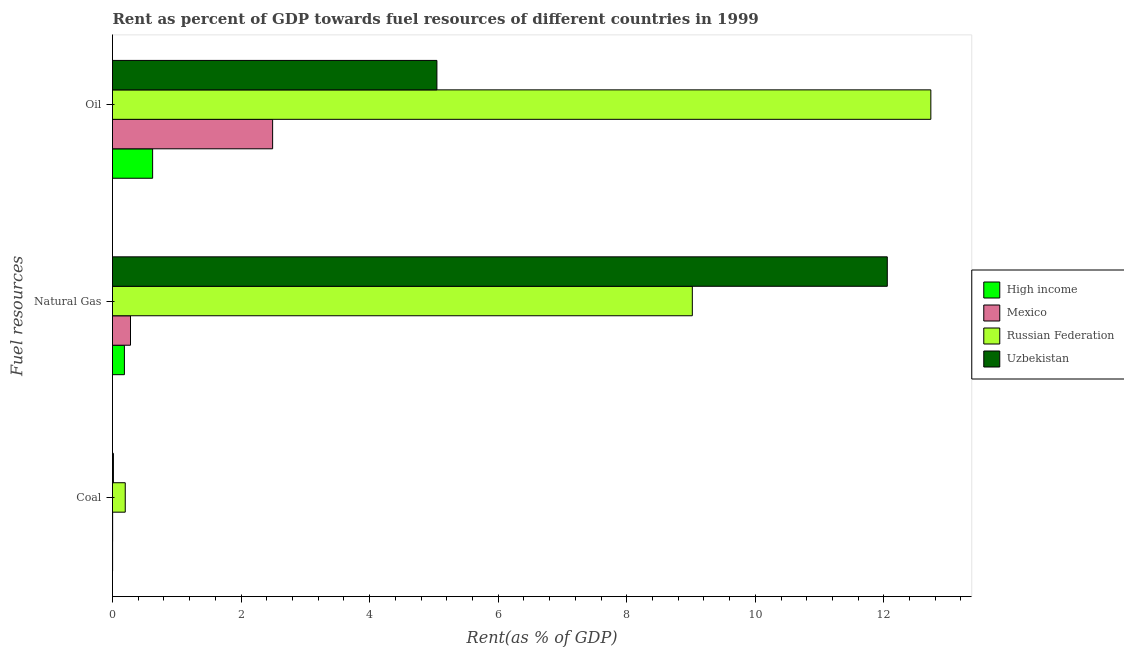How many different coloured bars are there?
Offer a terse response. 4. How many groups of bars are there?
Provide a short and direct response. 3. How many bars are there on the 2nd tick from the top?
Offer a terse response. 4. What is the label of the 1st group of bars from the top?
Ensure brevity in your answer.  Oil. What is the rent towards oil in Mexico?
Give a very brief answer. 2.49. Across all countries, what is the maximum rent towards coal?
Your response must be concise. 0.2. Across all countries, what is the minimum rent towards natural gas?
Give a very brief answer. 0.19. In which country was the rent towards coal maximum?
Provide a succinct answer. Russian Federation. In which country was the rent towards natural gas minimum?
Your answer should be very brief. High income. What is the total rent towards oil in the graph?
Your response must be concise. 20.89. What is the difference between the rent towards natural gas in Russian Federation and that in Uzbekistan?
Ensure brevity in your answer.  -3.03. What is the difference between the rent towards coal in High income and the rent towards natural gas in Russian Federation?
Your response must be concise. -9.02. What is the average rent towards coal per country?
Keep it short and to the point. 0.05. What is the difference between the rent towards natural gas and rent towards oil in Mexico?
Provide a succinct answer. -2.21. What is the ratio of the rent towards oil in High income to that in Uzbekistan?
Ensure brevity in your answer.  0.12. Is the rent towards natural gas in Russian Federation less than that in Uzbekistan?
Your response must be concise. Yes. What is the difference between the highest and the second highest rent towards natural gas?
Offer a very short reply. 3.03. What is the difference between the highest and the lowest rent towards natural gas?
Your answer should be compact. 11.87. In how many countries, is the rent towards oil greater than the average rent towards oil taken over all countries?
Your answer should be compact. 1. Is the sum of the rent towards natural gas in High income and Mexico greater than the maximum rent towards oil across all countries?
Make the answer very short. No. What does the 1st bar from the top in Oil represents?
Give a very brief answer. Uzbekistan. What does the 3rd bar from the bottom in Coal represents?
Provide a succinct answer. Russian Federation. Is it the case that in every country, the sum of the rent towards coal and rent towards natural gas is greater than the rent towards oil?
Provide a succinct answer. No. How many bars are there?
Provide a succinct answer. 12. What is the difference between two consecutive major ticks on the X-axis?
Provide a short and direct response. 2. Does the graph contain any zero values?
Ensure brevity in your answer.  No. Where does the legend appear in the graph?
Offer a terse response. Center right. How many legend labels are there?
Your answer should be compact. 4. What is the title of the graph?
Your answer should be very brief. Rent as percent of GDP towards fuel resources of different countries in 1999. What is the label or title of the X-axis?
Your response must be concise. Rent(as % of GDP). What is the label or title of the Y-axis?
Give a very brief answer. Fuel resources. What is the Rent(as % of GDP) of High income in Coal?
Your response must be concise. 0. What is the Rent(as % of GDP) in Mexico in Coal?
Ensure brevity in your answer.  0. What is the Rent(as % of GDP) in Russian Federation in Coal?
Your answer should be compact. 0.2. What is the Rent(as % of GDP) in Uzbekistan in Coal?
Make the answer very short. 0.01. What is the Rent(as % of GDP) of High income in Natural Gas?
Your answer should be compact. 0.19. What is the Rent(as % of GDP) in Mexico in Natural Gas?
Ensure brevity in your answer.  0.28. What is the Rent(as % of GDP) in Russian Federation in Natural Gas?
Keep it short and to the point. 9.02. What is the Rent(as % of GDP) of Uzbekistan in Natural Gas?
Provide a short and direct response. 12.05. What is the Rent(as % of GDP) of High income in Oil?
Ensure brevity in your answer.  0.62. What is the Rent(as % of GDP) of Mexico in Oil?
Your answer should be compact. 2.49. What is the Rent(as % of GDP) in Russian Federation in Oil?
Ensure brevity in your answer.  12.73. What is the Rent(as % of GDP) of Uzbekistan in Oil?
Offer a terse response. 5.05. Across all Fuel resources, what is the maximum Rent(as % of GDP) of High income?
Your response must be concise. 0.62. Across all Fuel resources, what is the maximum Rent(as % of GDP) in Mexico?
Provide a succinct answer. 2.49. Across all Fuel resources, what is the maximum Rent(as % of GDP) of Russian Federation?
Your response must be concise. 12.73. Across all Fuel resources, what is the maximum Rent(as % of GDP) of Uzbekistan?
Your answer should be compact. 12.05. Across all Fuel resources, what is the minimum Rent(as % of GDP) in High income?
Keep it short and to the point. 0. Across all Fuel resources, what is the minimum Rent(as % of GDP) of Mexico?
Offer a terse response. 0. Across all Fuel resources, what is the minimum Rent(as % of GDP) of Russian Federation?
Your answer should be compact. 0.2. Across all Fuel resources, what is the minimum Rent(as % of GDP) in Uzbekistan?
Your answer should be very brief. 0.01. What is the total Rent(as % of GDP) in High income in the graph?
Give a very brief answer. 0.81. What is the total Rent(as % of GDP) of Mexico in the graph?
Your answer should be compact. 2.77. What is the total Rent(as % of GDP) of Russian Federation in the graph?
Provide a succinct answer. 21.95. What is the total Rent(as % of GDP) in Uzbekistan in the graph?
Offer a very short reply. 17.11. What is the difference between the Rent(as % of GDP) in High income in Coal and that in Natural Gas?
Offer a very short reply. -0.18. What is the difference between the Rent(as % of GDP) of Mexico in Coal and that in Natural Gas?
Your answer should be compact. -0.28. What is the difference between the Rent(as % of GDP) in Russian Federation in Coal and that in Natural Gas?
Provide a short and direct response. -8.82. What is the difference between the Rent(as % of GDP) in Uzbekistan in Coal and that in Natural Gas?
Offer a terse response. -12.04. What is the difference between the Rent(as % of GDP) of High income in Coal and that in Oil?
Your response must be concise. -0.62. What is the difference between the Rent(as % of GDP) in Mexico in Coal and that in Oil?
Keep it short and to the point. -2.49. What is the difference between the Rent(as % of GDP) of Russian Federation in Coal and that in Oil?
Offer a terse response. -12.53. What is the difference between the Rent(as % of GDP) of Uzbekistan in Coal and that in Oil?
Give a very brief answer. -5.03. What is the difference between the Rent(as % of GDP) in High income in Natural Gas and that in Oil?
Give a very brief answer. -0.44. What is the difference between the Rent(as % of GDP) of Mexico in Natural Gas and that in Oil?
Your answer should be compact. -2.21. What is the difference between the Rent(as % of GDP) of Russian Federation in Natural Gas and that in Oil?
Make the answer very short. -3.71. What is the difference between the Rent(as % of GDP) in Uzbekistan in Natural Gas and that in Oil?
Ensure brevity in your answer.  7.01. What is the difference between the Rent(as % of GDP) of High income in Coal and the Rent(as % of GDP) of Mexico in Natural Gas?
Ensure brevity in your answer.  -0.28. What is the difference between the Rent(as % of GDP) of High income in Coal and the Rent(as % of GDP) of Russian Federation in Natural Gas?
Ensure brevity in your answer.  -9.02. What is the difference between the Rent(as % of GDP) of High income in Coal and the Rent(as % of GDP) of Uzbekistan in Natural Gas?
Your response must be concise. -12.05. What is the difference between the Rent(as % of GDP) of Mexico in Coal and the Rent(as % of GDP) of Russian Federation in Natural Gas?
Your answer should be compact. -9.02. What is the difference between the Rent(as % of GDP) in Mexico in Coal and the Rent(as % of GDP) in Uzbekistan in Natural Gas?
Provide a short and direct response. -12.05. What is the difference between the Rent(as % of GDP) in Russian Federation in Coal and the Rent(as % of GDP) in Uzbekistan in Natural Gas?
Ensure brevity in your answer.  -11.86. What is the difference between the Rent(as % of GDP) of High income in Coal and the Rent(as % of GDP) of Mexico in Oil?
Provide a short and direct response. -2.49. What is the difference between the Rent(as % of GDP) in High income in Coal and the Rent(as % of GDP) in Russian Federation in Oil?
Ensure brevity in your answer.  -12.73. What is the difference between the Rent(as % of GDP) of High income in Coal and the Rent(as % of GDP) of Uzbekistan in Oil?
Make the answer very short. -5.05. What is the difference between the Rent(as % of GDP) in Mexico in Coal and the Rent(as % of GDP) in Russian Federation in Oil?
Your response must be concise. -12.73. What is the difference between the Rent(as % of GDP) of Mexico in Coal and the Rent(as % of GDP) of Uzbekistan in Oil?
Your response must be concise. -5.04. What is the difference between the Rent(as % of GDP) in Russian Federation in Coal and the Rent(as % of GDP) in Uzbekistan in Oil?
Offer a terse response. -4.85. What is the difference between the Rent(as % of GDP) of High income in Natural Gas and the Rent(as % of GDP) of Mexico in Oil?
Offer a very short reply. -2.31. What is the difference between the Rent(as % of GDP) of High income in Natural Gas and the Rent(as % of GDP) of Russian Federation in Oil?
Your answer should be compact. -12.55. What is the difference between the Rent(as % of GDP) in High income in Natural Gas and the Rent(as % of GDP) in Uzbekistan in Oil?
Provide a succinct answer. -4.86. What is the difference between the Rent(as % of GDP) in Mexico in Natural Gas and the Rent(as % of GDP) in Russian Federation in Oil?
Give a very brief answer. -12.45. What is the difference between the Rent(as % of GDP) in Mexico in Natural Gas and the Rent(as % of GDP) in Uzbekistan in Oil?
Offer a very short reply. -4.77. What is the difference between the Rent(as % of GDP) in Russian Federation in Natural Gas and the Rent(as % of GDP) in Uzbekistan in Oil?
Ensure brevity in your answer.  3.97. What is the average Rent(as % of GDP) in High income per Fuel resources?
Your answer should be very brief. 0.27. What is the average Rent(as % of GDP) of Mexico per Fuel resources?
Offer a very short reply. 0.92. What is the average Rent(as % of GDP) in Russian Federation per Fuel resources?
Offer a terse response. 7.32. What is the average Rent(as % of GDP) in Uzbekistan per Fuel resources?
Your answer should be compact. 5.7. What is the difference between the Rent(as % of GDP) of High income and Rent(as % of GDP) of Mexico in Coal?
Provide a succinct answer. -0. What is the difference between the Rent(as % of GDP) in High income and Rent(as % of GDP) in Russian Federation in Coal?
Provide a short and direct response. -0.2. What is the difference between the Rent(as % of GDP) of High income and Rent(as % of GDP) of Uzbekistan in Coal?
Your answer should be very brief. -0.01. What is the difference between the Rent(as % of GDP) in Mexico and Rent(as % of GDP) in Russian Federation in Coal?
Your answer should be very brief. -0.2. What is the difference between the Rent(as % of GDP) of Mexico and Rent(as % of GDP) of Uzbekistan in Coal?
Your response must be concise. -0.01. What is the difference between the Rent(as % of GDP) of Russian Federation and Rent(as % of GDP) of Uzbekistan in Coal?
Your answer should be very brief. 0.18. What is the difference between the Rent(as % of GDP) in High income and Rent(as % of GDP) in Mexico in Natural Gas?
Your answer should be compact. -0.09. What is the difference between the Rent(as % of GDP) of High income and Rent(as % of GDP) of Russian Federation in Natural Gas?
Offer a very short reply. -8.84. What is the difference between the Rent(as % of GDP) in High income and Rent(as % of GDP) in Uzbekistan in Natural Gas?
Ensure brevity in your answer.  -11.87. What is the difference between the Rent(as % of GDP) in Mexico and Rent(as % of GDP) in Russian Federation in Natural Gas?
Your answer should be compact. -8.74. What is the difference between the Rent(as % of GDP) of Mexico and Rent(as % of GDP) of Uzbekistan in Natural Gas?
Provide a short and direct response. -11.77. What is the difference between the Rent(as % of GDP) in Russian Federation and Rent(as % of GDP) in Uzbekistan in Natural Gas?
Ensure brevity in your answer.  -3.03. What is the difference between the Rent(as % of GDP) in High income and Rent(as % of GDP) in Mexico in Oil?
Offer a terse response. -1.87. What is the difference between the Rent(as % of GDP) of High income and Rent(as % of GDP) of Russian Federation in Oil?
Ensure brevity in your answer.  -12.11. What is the difference between the Rent(as % of GDP) of High income and Rent(as % of GDP) of Uzbekistan in Oil?
Provide a succinct answer. -4.42. What is the difference between the Rent(as % of GDP) of Mexico and Rent(as % of GDP) of Russian Federation in Oil?
Offer a terse response. -10.24. What is the difference between the Rent(as % of GDP) in Mexico and Rent(as % of GDP) in Uzbekistan in Oil?
Offer a very short reply. -2.56. What is the difference between the Rent(as % of GDP) in Russian Federation and Rent(as % of GDP) in Uzbekistan in Oil?
Your answer should be very brief. 7.68. What is the ratio of the Rent(as % of GDP) in High income in Coal to that in Natural Gas?
Your answer should be compact. 0.01. What is the ratio of the Rent(as % of GDP) in Mexico in Coal to that in Natural Gas?
Provide a succinct answer. 0.01. What is the ratio of the Rent(as % of GDP) of Russian Federation in Coal to that in Natural Gas?
Offer a terse response. 0.02. What is the ratio of the Rent(as % of GDP) of Uzbekistan in Coal to that in Natural Gas?
Provide a succinct answer. 0. What is the ratio of the Rent(as % of GDP) of High income in Coal to that in Oil?
Ensure brevity in your answer.  0. What is the ratio of the Rent(as % of GDP) in Mexico in Coal to that in Oil?
Your answer should be compact. 0. What is the ratio of the Rent(as % of GDP) of Russian Federation in Coal to that in Oil?
Offer a very short reply. 0.02. What is the ratio of the Rent(as % of GDP) in Uzbekistan in Coal to that in Oil?
Your answer should be very brief. 0. What is the ratio of the Rent(as % of GDP) in High income in Natural Gas to that in Oil?
Your response must be concise. 0.3. What is the ratio of the Rent(as % of GDP) in Mexico in Natural Gas to that in Oil?
Your response must be concise. 0.11. What is the ratio of the Rent(as % of GDP) in Russian Federation in Natural Gas to that in Oil?
Keep it short and to the point. 0.71. What is the ratio of the Rent(as % of GDP) in Uzbekistan in Natural Gas to that in Oil?
Make the answer very short. 2.39. What is the difference between the highest and the second highest Rent(as % of GDP) in High income?
Offer a very short reply. 0.44. What is the difference between the highest and the second highest Rent(as % of GDP) in Mexico?
Ensure brevity in your answer.  2.21. What is the difference between the highest and the second highest Rent(as % of GDP) in Russian Federation?
Offer a terse response. 3.71. What is the difference between the highest and the second highest Rent(as % of GDP) of Uzbekistan?
Provide a short and direct response. 7.01. What is the difference between the highest and the lowest Rent(as % of GDP) in High income?
Your response must be concise. 0.62. What is the difference between the highest and the lowest Rent(as % of GDP) of Mexico?
Keep it short and to the point. 2.49. What is the difference between the highest and the lowest Rent(as % of GDP) in Russian Federation?
Your answer should be very brief. 12.53. What is the difference between the highest and the lowest Rent(as % of GDP) of Uzbekistan?
Your answer should be very brief. 12.04. 